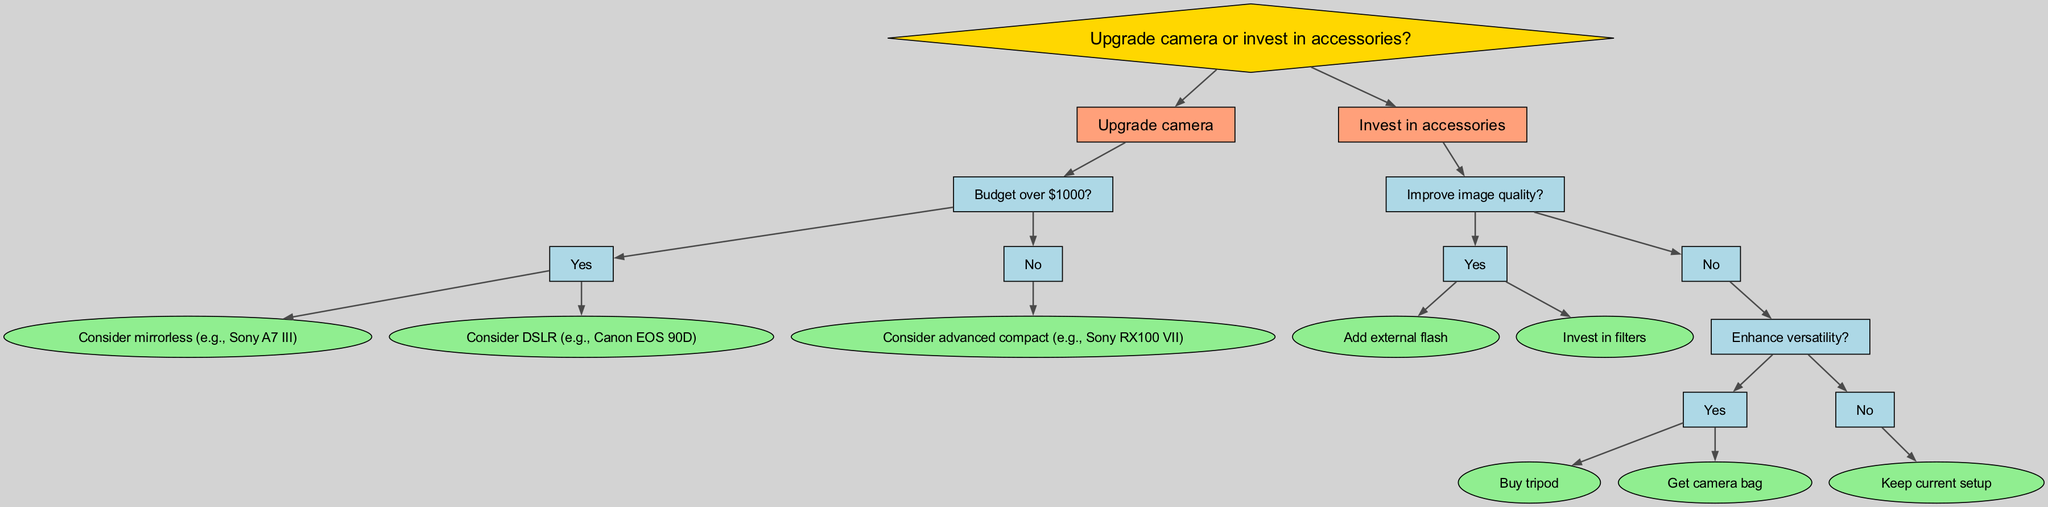What is the root node of the diagram? The root node is the starting point of the decision tree, representing the main question to be evaluated, which in this case is “Upgrade camera or invest in accessories?”
Answer: Upgrade camera or invest in accessories? How many main branches are there from the root? The root node has two distinct branches leading away from it, one for upgrading the camera and another for investing in accessories.
Answer: 2 If the decision is to upgrade the camera, what are the two options if the budget is over $1000? Under the condition of budgeting over $1000, the decision branches into two options, which are to consider a mirrorless camera or a DSLR.
Answer: Consider mirrorless (e.g., Sony A7 III) or consider DSLR (e.g., Canon EOS 90D) What accessory can be added to improve image quality? The diagram presents two options for enhancing image quality: adding an external flash and investing in filters.
Answer: Add external flash or invest in filters What happens if the answer to "Improve image quality?" is No under the accessories branch? If the response to improving image quality is No, the decision tree then evaluates whether to enhance versatility. If the answer is Yes, the options will be to buy a tripod or get a camera bag. If No, the final decision is to keep the current setup.
Answer: Enhance versatility? If the budget is under $1000 and the decision is to upgrade, what is the recommended camera? If the budget for upgrading is below $1000, the recommendation is to consider an advanced compact camera, specifically the Sony RX100 VII.
Answer: Consider advanced compact (e.g., Sony RX100 VII) How many final decisions can be made under the "Invest in accessories" branch? If we trace through the paths from the investments in accessories branch, there are three possible final decisions: adding an external flash, investing in filters, or keeping the current setup.
Answer: 3 What is the next step if the answer to "Enhance versatility?" is Yes? If the answer is Yes to enhancing versatility, then the next steps are to either buy a tripod or get a camera bag.
Answer: Buy tripod or get camera bag 